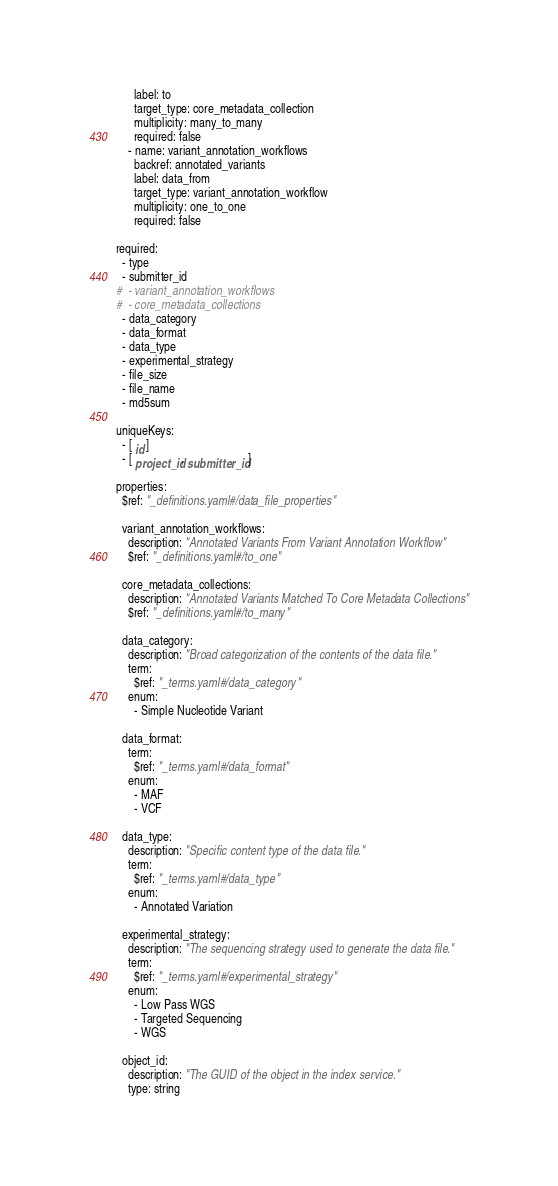<code> <loc_0><loc_0><loc_500><loc_500><_YAML_>      label: to
      target_type: core_metadata_collection
      multiplicity: many_to_many
      required: false
    - name: variant_annotation_workflows
      backref: annotated_variants
      label: data_from
      target_type: variant_annotation_workflow
      multiplicity: one_to_one
      required: false

required:
  - type
  - submitter_id
#  - variant_annotation_workflows
#  - core_metadata_collections
  - data_category
  - data_format
  - data_type
  - experimental_strategy
  - file_size
  - file_name
  - md5sum

uniqueKeys:
  - [ id ]
  - [ project_id, submitter_id ]

properties:
  $ref: "_definitions.yaml#/data_file_properties"

  variant_annotation_workflows:
    description: "Annotated Variants From Variant Annotation Workflow"
    $ref: "_definitions.yaml#/to_one"

  core_metadata_collections:
    description: "Annotated Variants Matched To Core Metadata Collections"
    $ref: "_definitions.yaml#/to_many"

  data_category:
    description: "Broad categorization of the contents of the data file."
    term:
      $ref: "_terms.yaml#/data_category"
    enum:
      - Simple Nucleotide Variant

  data_format:
    term:
      $ref: "_terms.yaml#/data_format"
    enum:
      - MAF
      - VCF

  data_type:
    description: "Specific content type of the data file."
    term:
      $ref: "_terms.yaml#/data_type"
    enum:
      - Annotated Variation

  experimental_strategy:
    description: "The sequencing strategy used to generate the data file."
    term:
      $ref: "_terms.yaml#/experimental_strategy"
    enum:
      - Low Pass WGS
      - Targeted Sequencing
      - WGS

  object_id:
    description: "The GUID of the object in the index service."
    type: string
</code> 